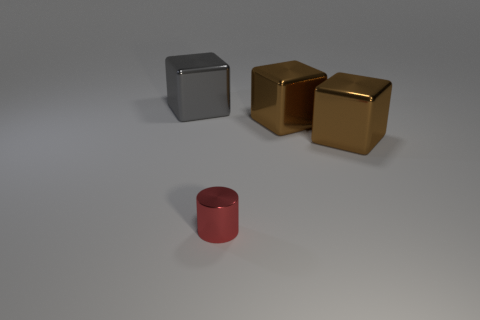Subtract all brown cylinders. How many brown cubes are left? 2 Add 4 yellow cylinders. How many objects exist? 8 Subtract all gray metallic blocks. How many blocks are left? 2 Subtract all cylinders. How many objects are left? 3 Subtract 1 blocks. How many blocks are left? 2 Subtract all green cubes. Subtract all blue balls. How many cubes are left? 3 Add 4 tiny green shiny objects. How many tiny green shiny objects exist? 4 Subtract 0 green spheres. How many objects are left? 4 Subtract all red things. Subtract all big gray blocks. How many objects are left? 2 Add 3 tiny red cylinders. How many tiny red cylinders are left? 4 